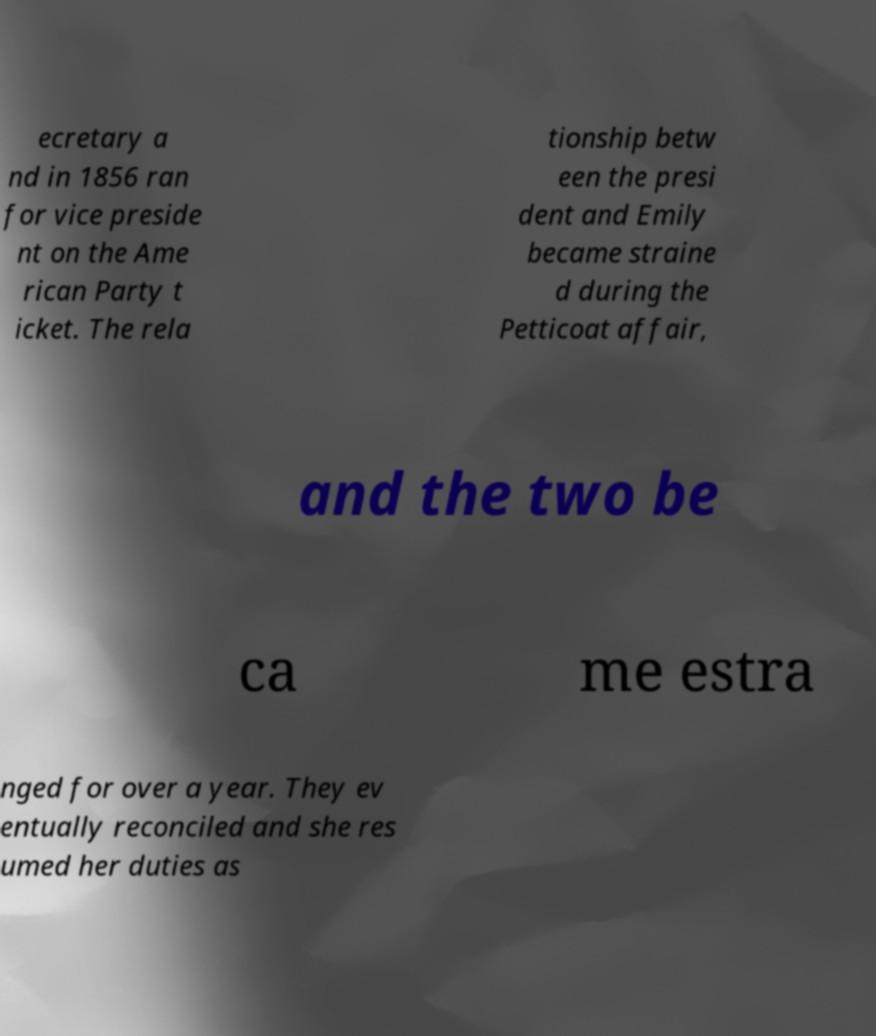There's text embedded in this image that I need extracted. Can you transcribe it verbatim? ecretary a nd in 1856 ran for vice preside nt on the Ame rican Party t icket. The rela tionship betw een the presi dent and Emily became straine d during the Petticoat affair, and the two be ca me estra nged for over a year. They ev entually reconciled and she res umed her duties as 